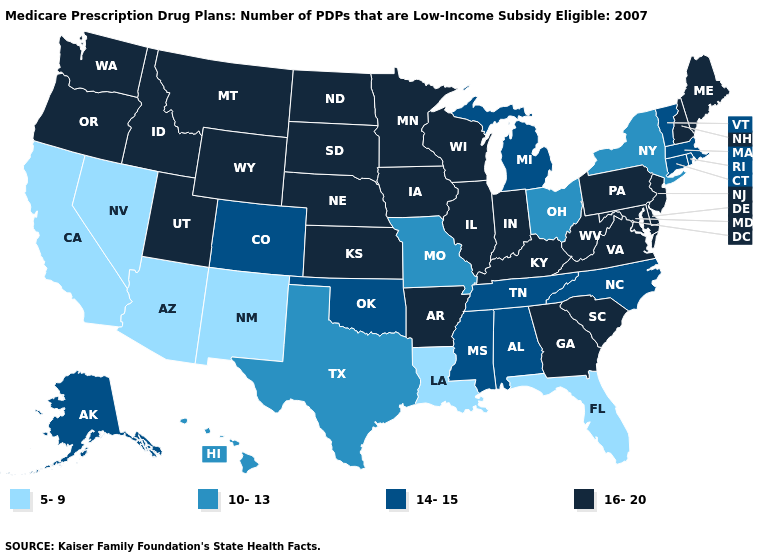Is the legend a continuous bar?
Short answer required. No. What is the highest value in the Northeast ?
Answer briefly. 16-20. Does Texas have the same value as Kansas?
Give a very brief answer. No. How many symbols are there in the legend?
Keep it brief. 4. Name the states that have a value in the range 10-13?
Answer briefly. Hawaii, Missouri, New York, Ohio, Texas. Name the states that have a value in the range 14-15?
Write a very short answer. Alaska, Alabama, Colorado, Connecticut, Massachusetts, Michigan, Mississippi, North Carolina, Oklahoma, Rhode Island, Tennessee, Vermont. Which states have the lowest value in the West?
Short answer required. Arizona, California, New Mexico, Nevada. What is the lowest value in the USA?
Concise answer only. 5-9. Name the states that have a value in the range 10-13?
Keep it brief. Hawaii, Missouri, New York, Ohio, Texas. Among the states that border New York , which have the highest value?
Write a very short answer. New Jersey, Pennsylvania. What is the value of Montana?
Keep it brief. 16-20. Name the states that have a value in the range 5-9?
Keep it brief. Arizona, California, Florida, Louisiana, New Mexico, Nevada. Which states hav the highest value in the MidWest?
Keep it brief. Iowa, Illinois, Indiana, Kansas, Minnesota, North Dakota, Nebraska, South Dakota, Wisconsin. Name the states that have a value in the range 16-20?
Keep it brief. Arkansas, Delaware, Georgia, Iowa, Idaho, Illinois, Indiana, Kansas, Kentucky, Maryland, Maine, Minnesota, Montana, North Dakota, Nebraska, New Hampshire, New Jersey, Oregon, Pennsylvania, South Carolina, South Dakota, Utah, Virginia, Washington, Wisconsin, West Virginia, Wyoming. Does New Hampshire have the highest value in the USA?
Answer briefly. Yes. 